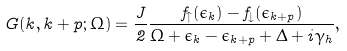<formula> <loc_0><loc_0><loc_500><loc_500>G ( k , k + p ; \Omega ) = \frac { J } { 2 } \frac { f _ { \uparrow } ( \epsilon _ { k } ) - f _ { \downarrow } ( \epsilon _ { k + p } ) } { \Omega + \epsilon _ { k } - \epsilon _ { k + p } + \Delta + i \gamma _ { h } } ,</formula> 